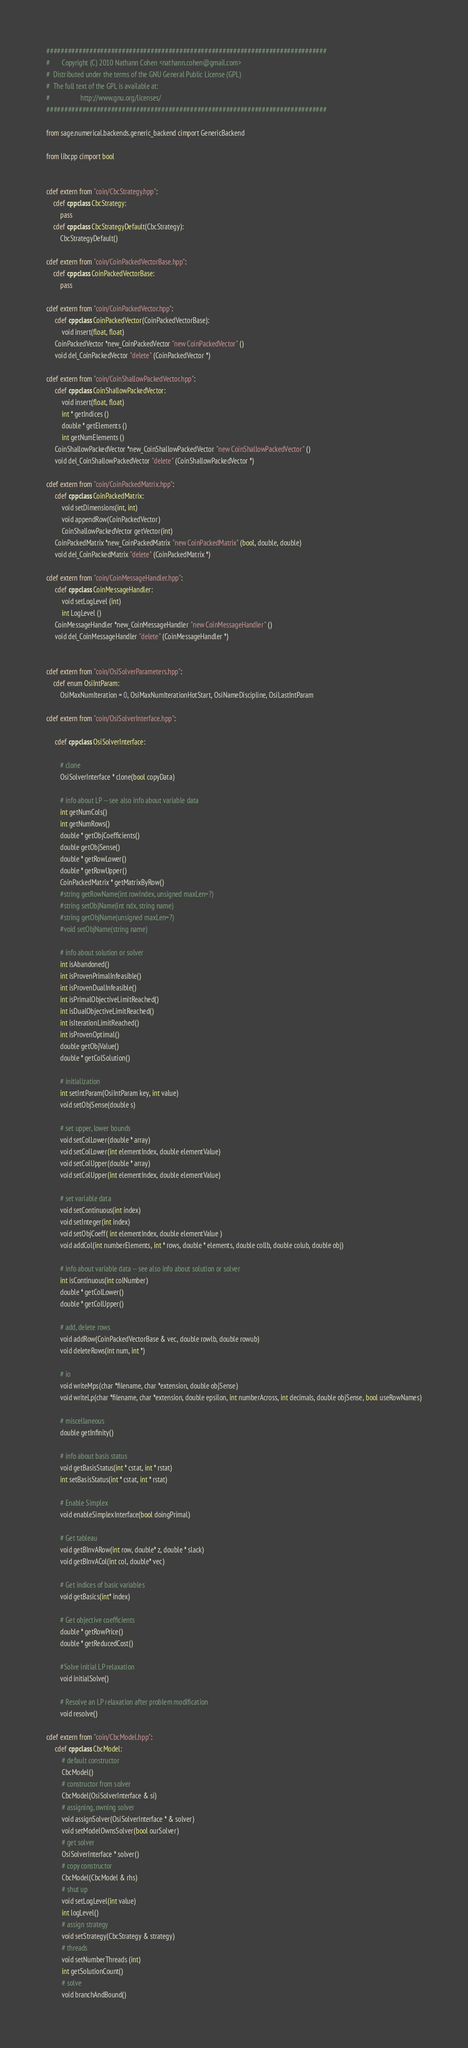Convert code to text. <code><loc_0><loc_0><loc_500><loc_500><_Cython_>##############################################################################
#       Copyright (C) 2010 Nathann Cohen <nathann.cohen@gmail.com>
#  Distributed under the terms of the GNU General Public License (GPL)
#  The full text of the GPL is available at:
#                  http://www.gnu.org/licenses/
##############################################################################

from sage.numerical.backends.generic_backend cimport GenericBackend

from libcpp cimport bool


cdef extern from "coin/CbcStrategy.hpp":
    cdef cppclass CbcStrategy:
        pass
    cdef cppclass CbcStrategyDefault(CbcStrategy):
        CbcStrategyDefault()

cdef extern from "coin/CoinPackedVectorBase.hpp":
    cdef cppclass CoinPackedVectorBase:
        pass

cdef extern from "coin/CoinPackedVector.hpp":
     cdef cppclass CoinPackedVector(CoinPackedVectorBase):
         void insert(float, float)
     CoinPackedVector *new_CoinPackedVector "new CoinPackedVector" ()
     void del_CoinPackedVector "delete" (CoinPackedVector *)

cdef extern from "coin/CoinShallowPackedVector.hpp":
     cdef cppclass CoinShallowPackedVector:
         void insert(float, float)
         int * getIndices ()
         double * getElements ()
         int getNumElements ()
     CoinShallowPackedVector *new_CoinShallowPackedVector "new CoinShallowPackedVector" ()
     void del_CoinShallowPackedVector "delete" (CoinShallowPackedVector *)

cdef extern from "coin/CoinPackedMatrix.hpp":
     cdef cppclass CoinPackedMatrix:
         void setDimensions(int, int)
         void appendRow(CoinPackedVector)
         CoinShallowPackedVector getVector(int)
     CoinPackedMatrix *new_CoinPackedMatrix "new CoinPackedMatrix" (bool, double, double)
     void del_CoinPackedMatrix "delete" (CoinPackedMatrix *)

cdef extern from "coin/CoinMessageHandler.hpp":
     cdef cppclass CoinMessageHandler:
         void setLogLevel (int)
         int LogLevel ()
     CoinMessageHandler *new_CoinMessageHandler "new CoinMessageHandler" ()
     void del_CoinMessageHandler "delete" (CoinMessageHandler *)


cdef extern from "coin/OsiSolverParameters.hpp":
    cdef enum OsiIntParam:
        OsiMaxNumIteration = 0, OsiMaxNumIterationHotStart, OsiNameDiscipline, OsiLastIntParam

cdef extern from "coin/OsiSolverInterface.hpp":

     cdef cppclass OsiSolverInterface:

        # clone
        OsiSolverInterface * clone(bool copyData)

        # info about LP -- see also info about variable data
        int getNumCols()
        int getNumRows()
        double * getObjCoefficients()
        double getObjSense()
        double * getRowLower()
        double * getRowUpper()
        CoinPackedMatrix * getMatrixByRow()
        #string getRowName(int rowIndex, unsigned maxLen=?)
        #string setObjName(int ndx, string name)
        #string getObjName(unsigned maxLen=?)
        #void setObjName(string name)

        # info about solution or solver
        int isAbandoned()
        int isProvenPrimalInfeasible()
        int isProvenDualInfeasible()
        int isPrimalObjectiveLimitReached()
        int isDualObjectiveLimitReached()
        int isIterationLimitReached()
        int isProvenOptimal()
        double getObjValue()
        double * getColSolution()

        # initialization
        int setIntParam(OsiIntParam key, int value)
        void setObjSense(double s)

        # set upper, lower bounds
        void setColLower(double * array)
        void setColLower(int elementIndex, double elementValue)
        void setColUpper(double * array)
        void setColUpper(int elementIndex, double elementValue)

        # set variable data
        void setContinuous(int index)
        void setInteger(int index)
        void setObjCoeff( int elementIndex, double elementValue )
        void addCol(int numberElements, int * rows, double * elements, double collb, double colub, double obj)

        # info about variable data -- see also info about solution or solver
        int isContinuous(int colNumber)
        double * getColLower()
        double * getColUpper()

        # add, delete rows
        void addRow(CoinPackedVectorBase & vec, double rowlb, double rowub)
        void deleteRows(int num, int *)

        # io
        void writeMps(char *filename, char *extension, double objSense)
        void writeLp(char *filename, char *extension, double epsilon, int numberAcross, int decimals, double objSense, bool useRowNames)

        # miscellaneous
        double getInfinity()

        # info about basis status
        void getBasisStatus(int * cstat, int * rstat)
        int setBasisStatus(int * cstat, int * rstat)

        # Enable Simplex
        void enableSimplexInterface(bool doingPrimal)

        # Get tableau
        void getBInvARow(int row, double* z, double * slack)
        void getBInvACol(int col, double* vec)

        # Get indices of basic variables
        void getBasics(int* index)

        # Get objective coefficients
        double * getRowPrice()
        double * getReducedCost()

        #Solve initial LP relaxation
        void initialSolve()

        # Resolve an LP relaxation after problem modification
        void resolve()

cdef extern from "coin/CbcModel.hpp":
     cdef cppclass CbcModel:
         # default constructor
         CbcModel()
         # constructor from solver
         CbcModel(OsiSolverInterface & si)
         # assigning, owning solver
         void assignSolver(OsiSolverInterface * & solver)
         void setModelOwnsSolver(bool ourSolver)
         # get solver
         OsiSolverInterface * solver()
         # copy constructor
         CbcModel(CbcModel & rhs)
         # shut up
         void setLogLevel(int value)
         int logLevel()
         # assign strategy
         void setStrategy(CbcStrategy & strategy)
         # threads
         void setNumberThreads (int)
         int getSolutionCount()
         # solve
         void branchAndBound()</code> 